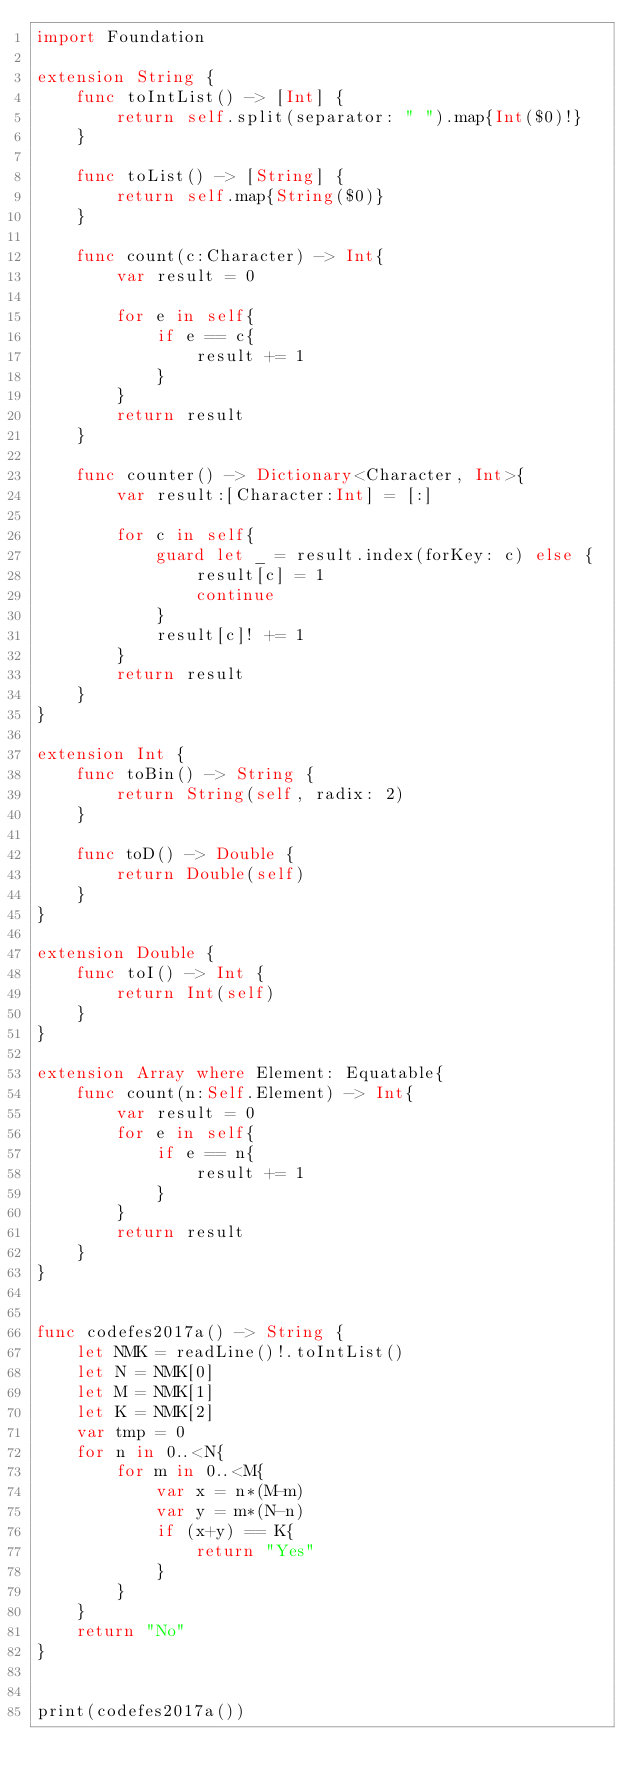<code> <loc_0><loc_0><loc_500><loc_500><_Swift_>import Foundation

extension String {
    func toIntList() -> [Int] {
        return self.split(separator: " ").map{Int($0)!}
    }
    
    func toList() -> [String] {
        return self.map{String($0)}
    }
    
    func count(c:Character) -> Int{
        var result = 0

        for e in self{
            if e == c{
                result += 1
            }
        }
        return result
    }

    func counter() -> Dictionary<Character, Int>{
        var result:[Character:Int] = [:]
        
        for c in self{
            guard let _ = result.index(forKey: c) else {
                result[c] = 1
                continue
            }
            result[c]! += 1
        }
        return result
    }
}

extension Int {
    func toBin() -> String {
        return String(self, radix: 2)
    }
    
    func toD() -> Double {
        return Double(self)
    }
}

extension Double {
    func toI() -> Int {
        return Int(self)
    }
}

extension Array where Element: Equatable{
    func count(n:Self.Element) -> Int{
        var result = 0
        for e in self{
            if e == n{
                result += 1
            }
        }
        return result
    }
}


func codefes2017a() -> String {
    let NMK = readLine()!.toIntList()
    let N = NMK[0]
    let M = NMK[1]
    let K = NMK[2]
    var tmp = 0
    for n in 0..<N{
        for m in 0..<M{
            var x = n*(M-m)
            var y = m*(N-n)
            if (x+y) == K{
                return "Yes"
            }
        }
    }
    return "No"
}


print(codefes2017a())
</code> 